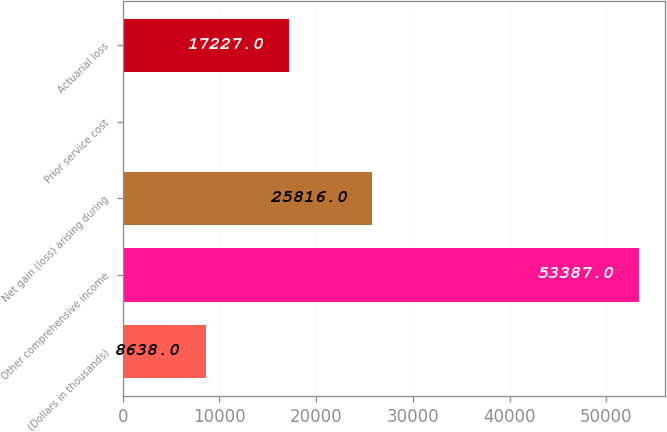Convert chart to OTSL. <chart><loc_0><loc_0><loc_500><loc_500><bar_chart><fcel>(Dollars in thousands)<fcel>Other comprehensive income<fcel>Net gain (loss) arising during<fcel>Prior service cost<fcel>Actuarial loss<nl><fcel>8638<fcel>53387<fcel>25816<fcel>49<fcel>17227<nl></chart> 